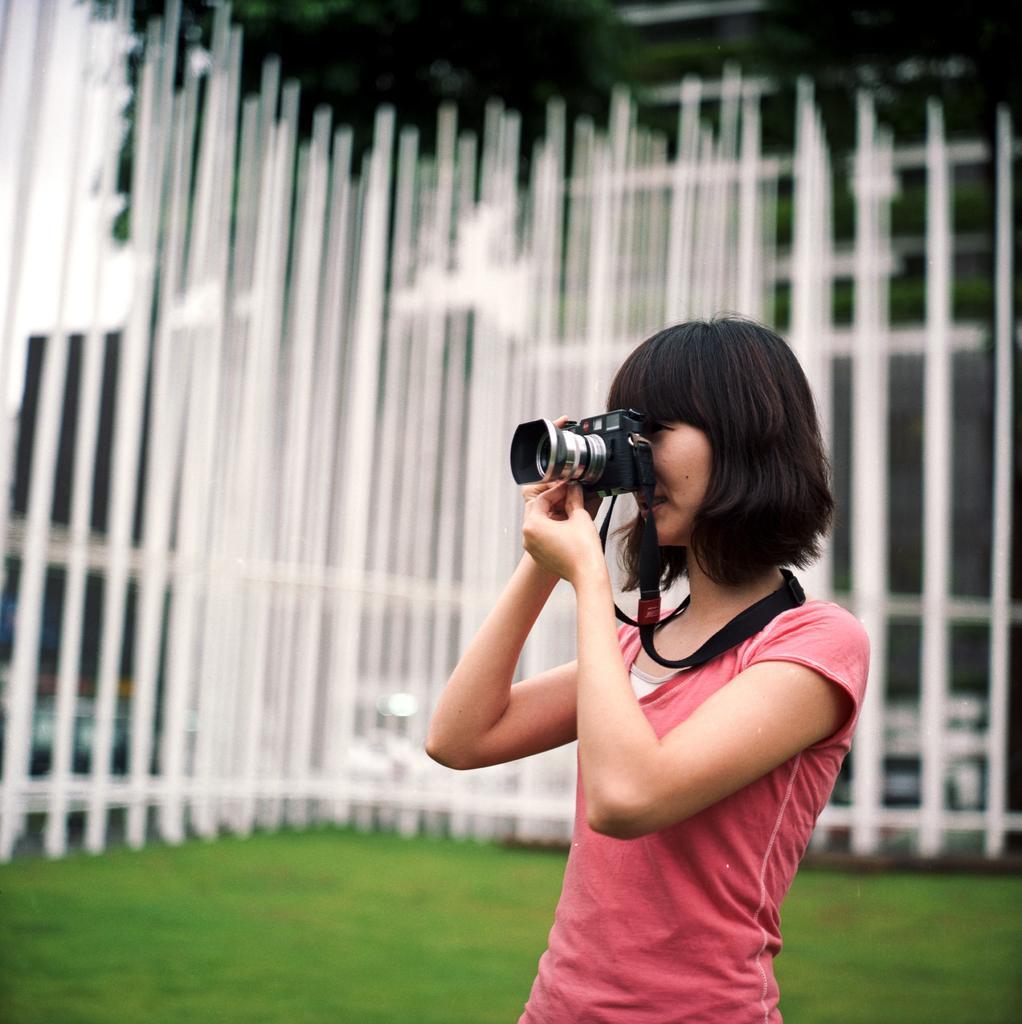Can you describe this image briefly? In this Picture we can see a girl in the park wearing a pink T- shirt with boy cut hair is standing and holding a camera in this hand and taking picture, Behind we can see the white long iron fencing and trees. 